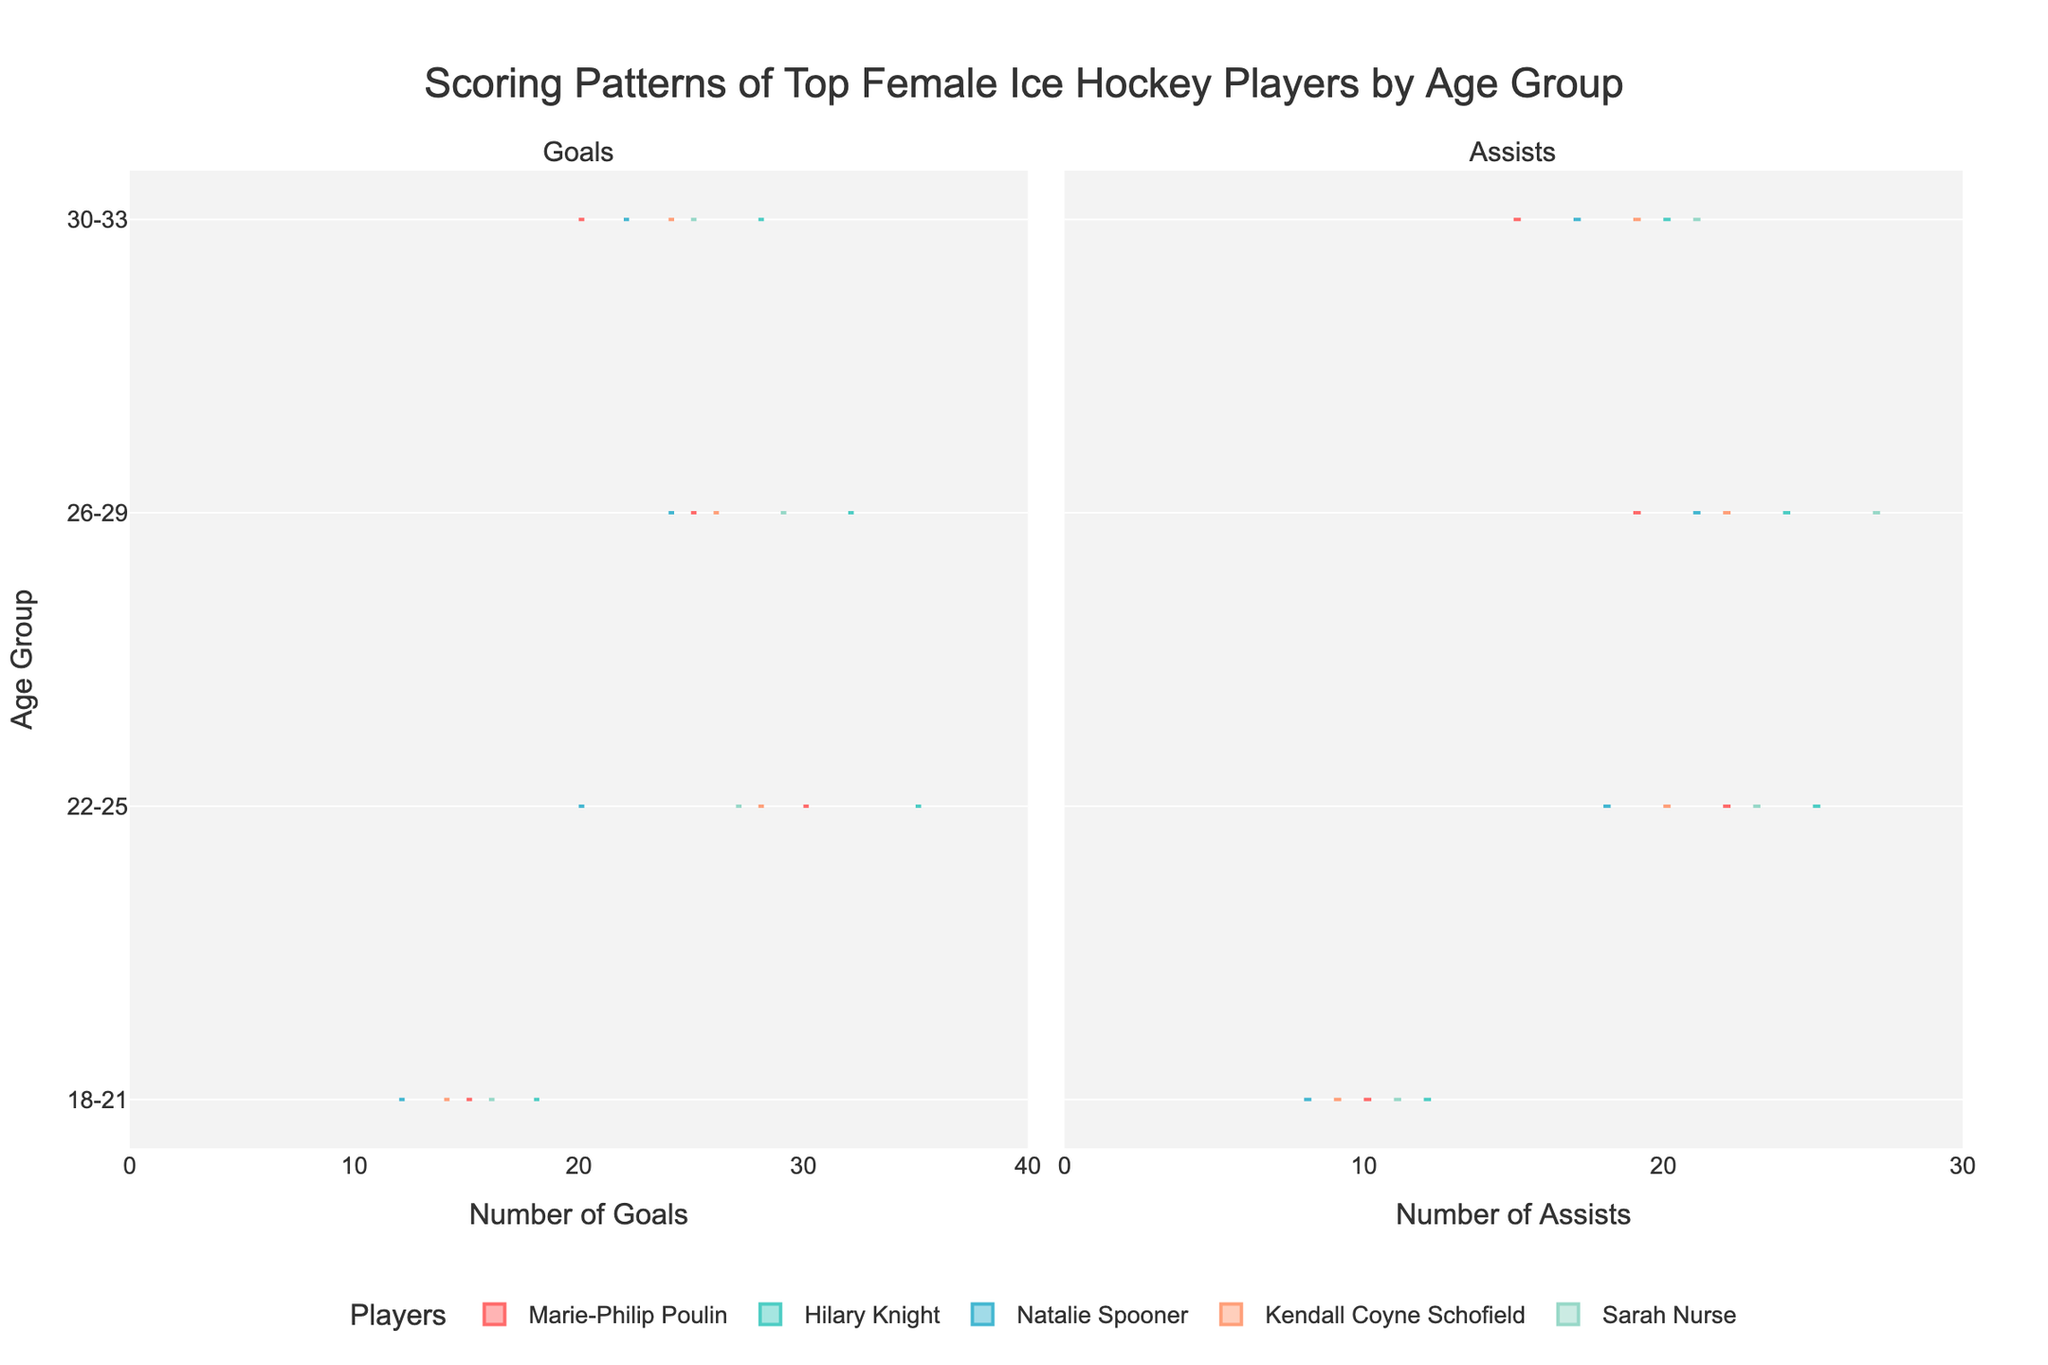What age group has the highest number of goals on average? To find which age group has the highest number of goals on average, you need to compare the median or peak values for the distribution of goals across all age groups. From the violin plot, examine each age dataset to identify the highest median level.
Answer: 22-25 Who has the most assists in the 26-29 age group? Look at the violin plot for assists within the 26-29 age group for each player. The player with the highest median value or the thickest part of the violin plot has the most assists.
Answer: Sarah Nurse Is there an age group where goals and assists are roughly equal for most players? To determine this, compare the plots for goals and assists across all age groups. Look for an age group where the distribution for goals and assists overlaps or closely matches for most players.
Answer: 26-29 Which player has the most significant decrease in goals from one age group to the next? Compare the distribution of goals (medians and ranges) for each player across consecutive age groups. Identify the player whose goals drop the most between any two age groups.
Answer: Hilary Knight from 22-25 to 26-29 Have assists for any player consistently increased across all age groups? For each player, examine the violin plots for assists across all age groups. Identify if any player's assist distribution trend is consistently upward from 18-21 to 30-33.
Answer: No player has consistently increasing assists across all age groups What is the average number of goals for Natalie Spooner in the 30-33 age group? Locate the violin plot for Natalie Spooner's goals in the 30-33 age group. The vertical thickness at the central (median) part of the violin gives the average value.
Answer: 22 Is there an age group with a noticeable increase in assist variance for any player? Look at the width and spread of the violin plots in the assists' subplot across all age groups. Identify any age group with a visibly broader spread for any one player, which indicates higher variance.
Answer: 26-29 for Kendall Coyne Schofield Which age group shows the highest performance variability in goals for Marie-Philip Poulin? Examine the width and distribution shape of the violin plots for Marie-Philip Poulin's goals across all age groups. The age group with the widest plot indicates the highest variability.
Answer: 18-21 How does Sarah Nurse's goal performance in 30-33 compare to her performance in 18-21? Compare the violin plots for Sarah Nurse's goals in the 30-33 age group and the 18-21 age group. Assess the central tendencies (medians) and distribution spread.
Answer: 30-33 is higher Who has the highest overall assist count, and in which age group do they achieve it? Compare the violin plots for assists for all players within each age group. Identify the highest peak and the age group for that value.
Answer: Sarah Nurse in 26-29 